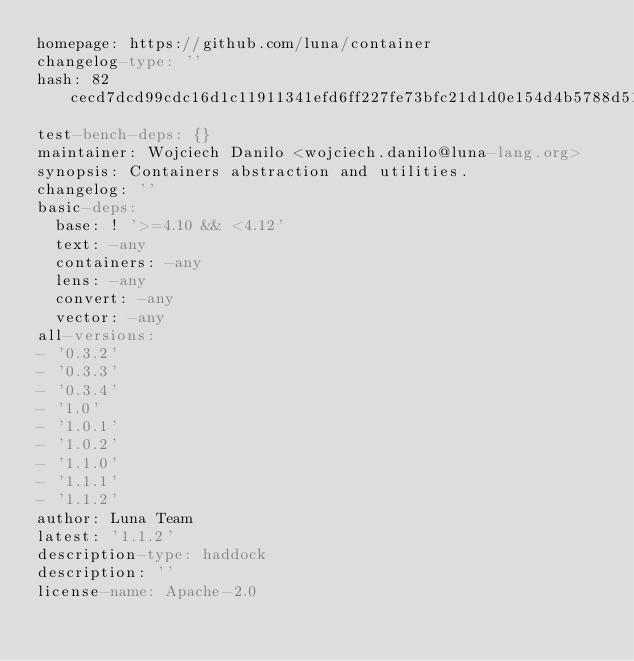<code> <loc_0><loc_0><loc_500><loc_500><_YAML_>homepage: https://github.com/luna/container
changelog-type: ''
hash: 82cecd7dcd99cdc16d1c11911341efd6ff227fe73bfc21d1d0e154d4b5788d51
test-bench-deps: {}
maintainer: Wojciech Danilo <wojciech.danilo@luna-lang.org>
synopsis: Containers abstraction and utilities.
changelog: ''
basic-deps:
  base: ! '>=4.10 && <4.12'
  text: -any
  containers: -any
  lens: -any
  convert: -any
  vector: -any
all-versions:
- '0.3.2'
- '0.3.3'
- '0.3.4'
- '1.0'
- '1.0.1'
- '1.0.2'
- '1.1.0'
- '1.1.1'
- '1.1.2'
author: Luna Team
latest: '1.1.2'
description-type: haddock
description: ''
license-name: Apache-2.0
</code> 